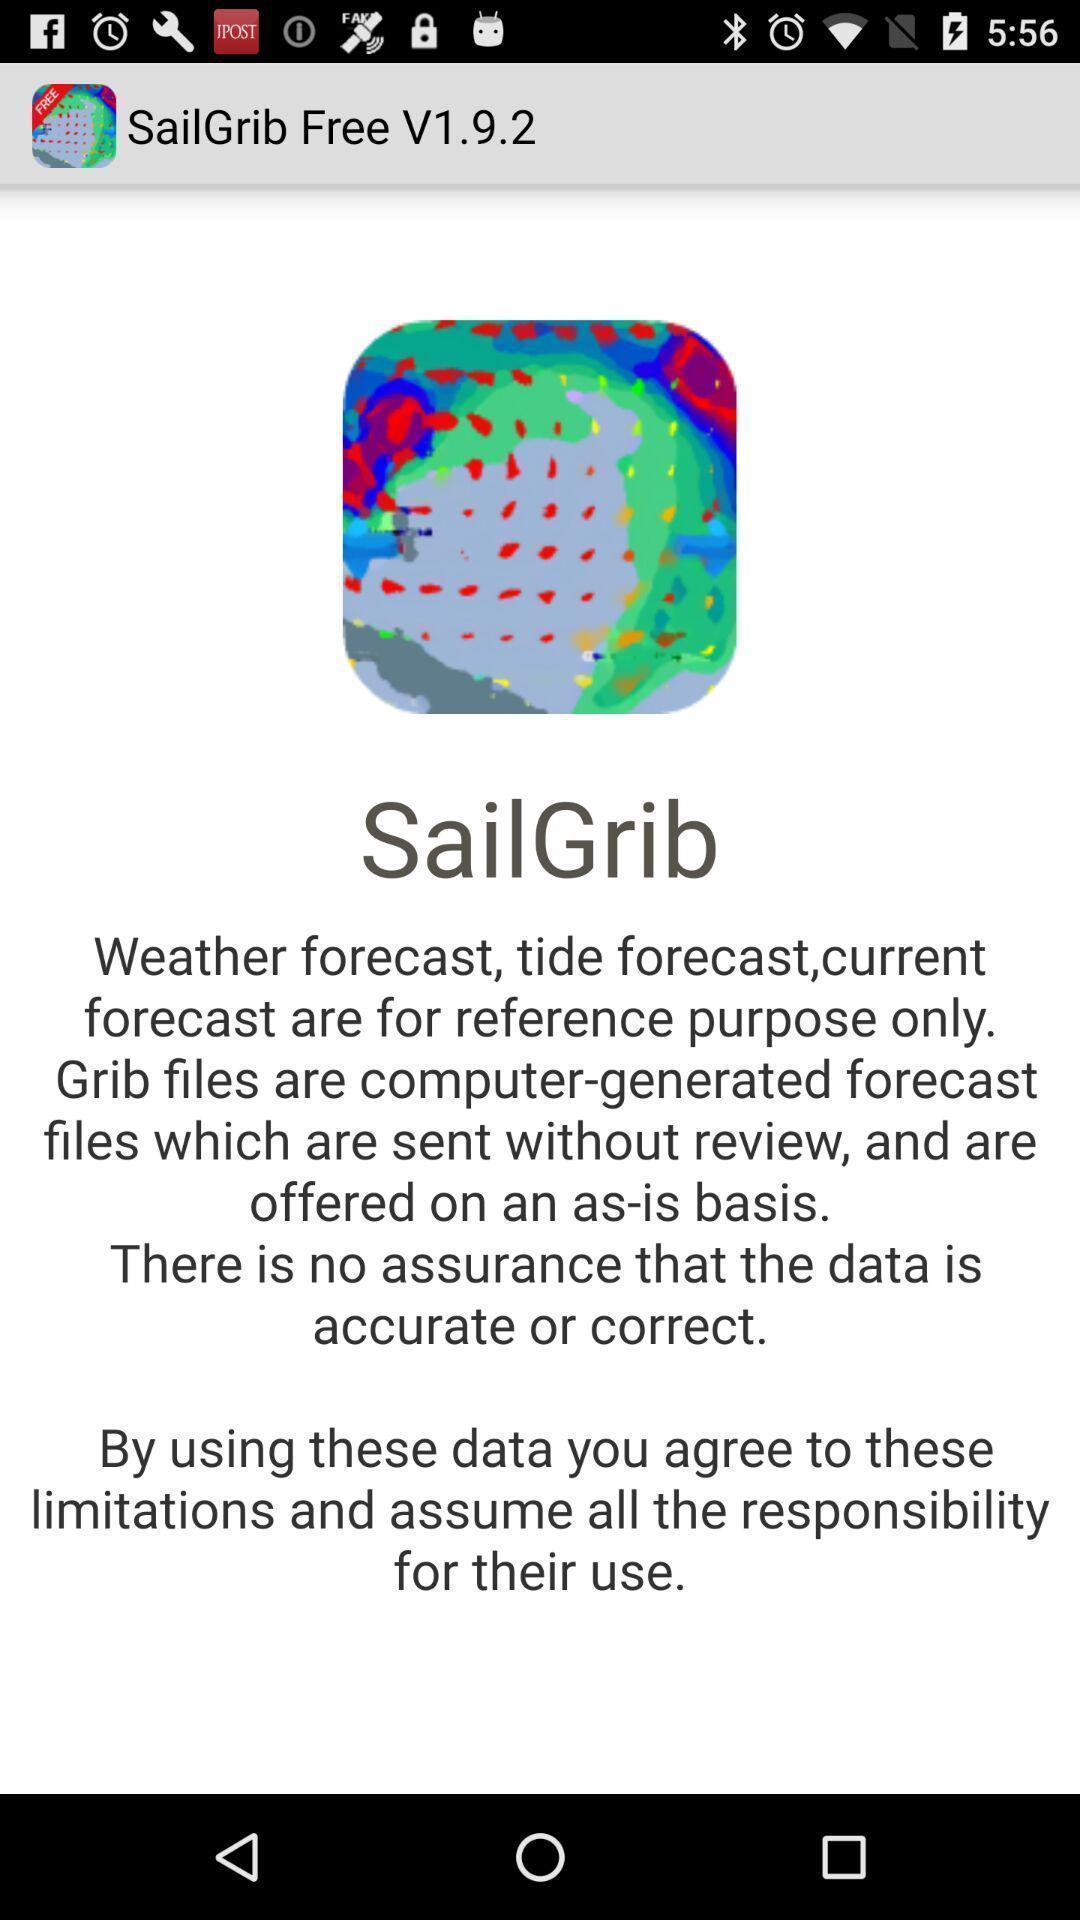Summarize the main components in this picture. Welcome page of weather app. 